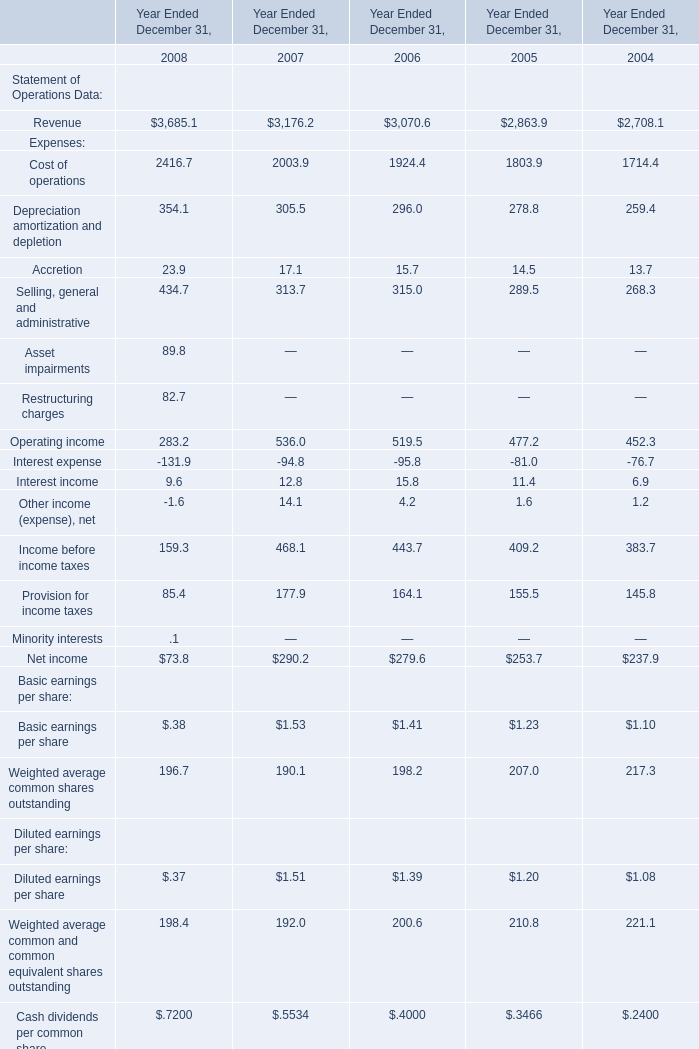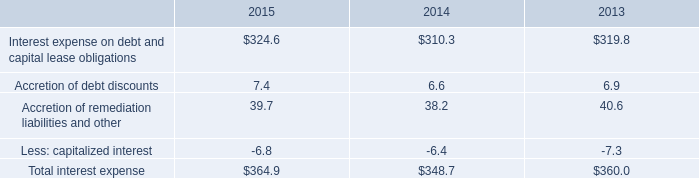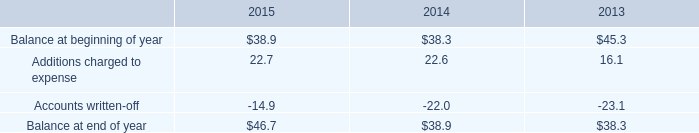What is the sum of Cost of operations, Depreciation amortization and depletion and Accretion of Expenses: in 2006 for Year Ended December 31,? 
Computations: ((1924.4 + 296.0) + 15.7)
Answer: 2236.1. 